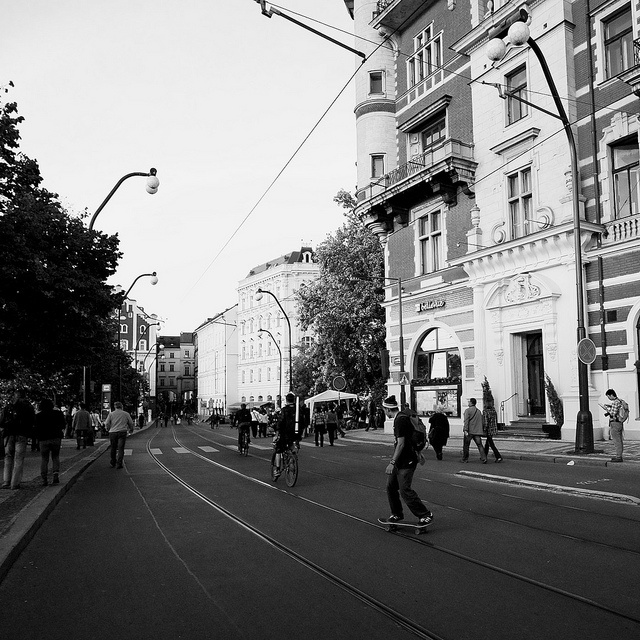Describe the objects in this image and their specific colors. I can see people in lightgray, black, gray, and darkgray tones, people in lightgray, black, gray, and darkgray tones, people in black, gray, and lightgray tones, people in black, gray, and lightgray tones, and people in lightgray, black, gray, and darkgray tones in this image. 